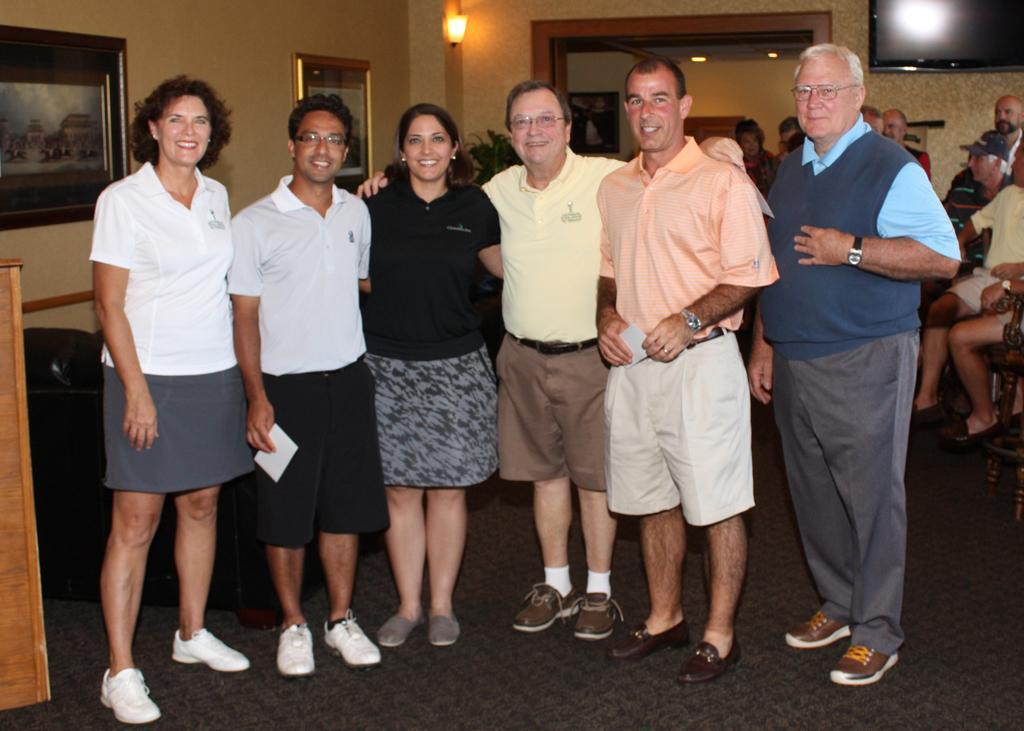Please provide a concise description of this image. In this image in the front there are persons standing and smiling. In the background there is a plant and there are frames on the wall, there is a light hanging and there are persons standing and sitting and there is a TV on the wall. On the left side there is a wooden stand and there is an object which is black in colour. 